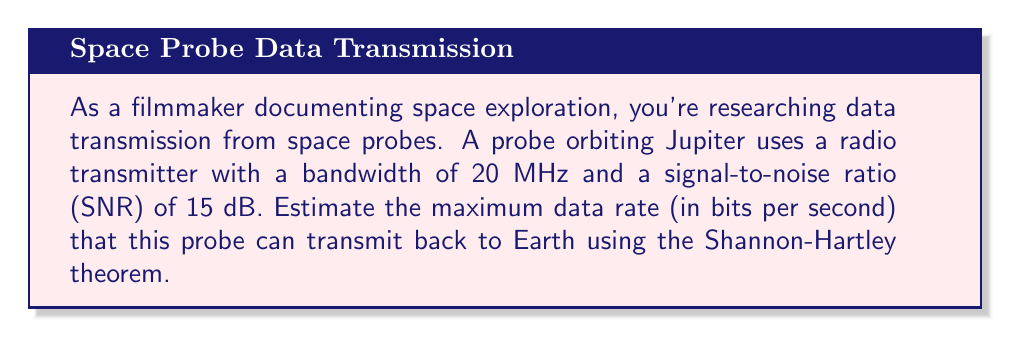Provide a solution to this math problem. To solve this problem, we'll use the Shannon-Hartley theorem, which gives the channel capacity for a communications channel subject to Gaussian noise. The theorem is expressed as:

$$C = B \log_2(1 + SNR)$$

Where:
$C$ = Channel capacity (bits per second)
$B$ = Bandwidth (Hz)
$SNR$ = Signal-to-noise ratio (linear, not dB)

Given:
- Bandwidth (B) = 20 MHz = $20 \times 10^6$ Hz
- SNR = 15 dB

Step 1: Convert SNR from dB to linear scale
SNR in dB = $10 \log_{10}(SNR)$
$15 = 10 \log_{10}(SNR)$
$1.5 = \log_{10}(SNR)$
$SNR = 10^{1.5} \approx 31.6228$

Step 2: Apply the Shannon-Hartley theorem
$$\begin{align}
C &= B \log_2(1 + SNR) \\
&= (20 \times 10^6) \log_2(1 + 31.6228) \\
&= (20 \times 10^6) \log_2(32.6228) \\
&= (20 \times 10^6) (5.0279) \\
&= 100.558 \times 10^6 \text{ bits per second}
\end{align}$$

Step 3: Round to a reasonable number of significant figures
$C \approx 101 \times 10^6 \text{ bits per second} = 101 \text{ Mbps}$

This result represents the theoretical maximum data rate for the given channel. In practice, the actual data rate would be lower due to various factors such as error correction overhead, protocol inefficiencies, and limitations of the transmitting and receiving equipment.
Answer: The estimated maximum data rate that the space probe can transmit back to Earth is approximately 101 Mbps (megabits per second). 